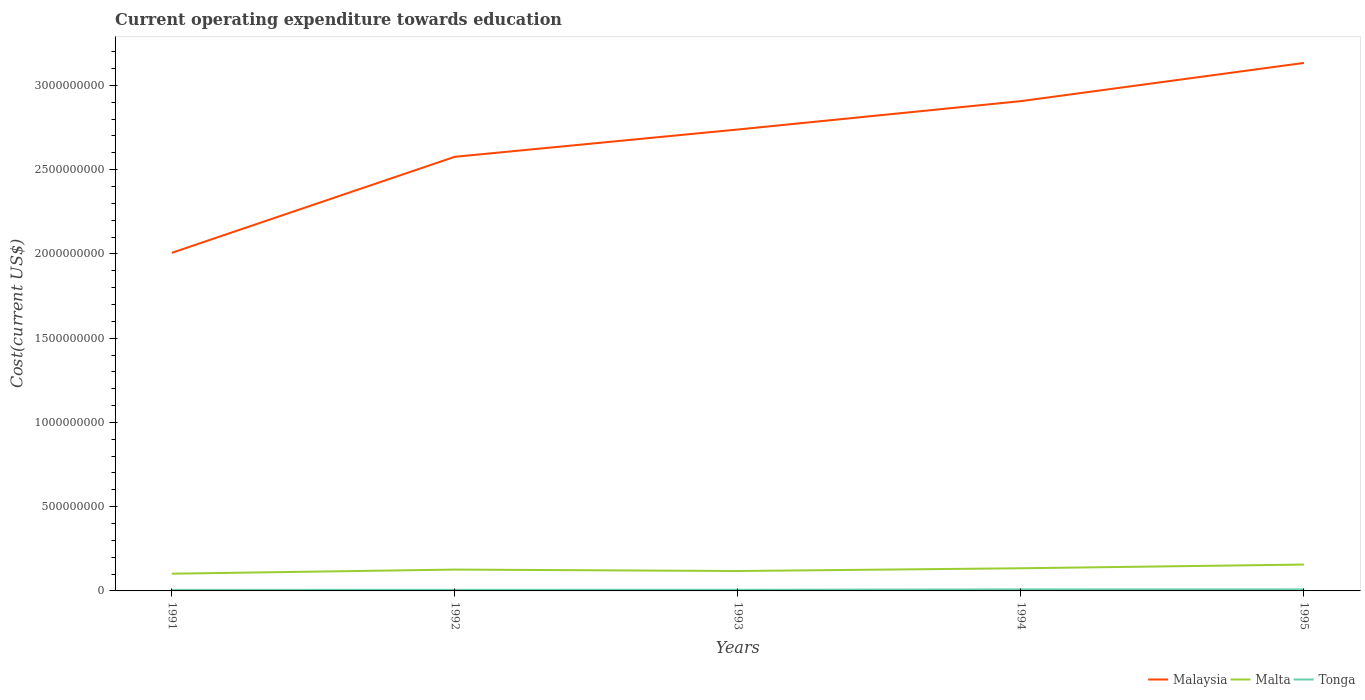Across all years, what is the maximum expenditure towards education in Malaysia?
Your answer should be very brief. 2.01e+09. In which year was the expenditure towards education in Malaysia maximum?
Give a very brief answer. 1991. What is the total expenditure towards education in Tonga in the graph?
Offer a terse response. -5.51e+05. What is the difference between the highest and the second highest expenditure towards education in Malta?
Offer a terse response. 5.43e+07. How many years are there in the graph?
Give a very brief answer. 5. What is the difference between two consecutive major ticks on the Y-axis?
Ensure brevity in your answer.  5.00e+08. Does the graph contain grids?
Your response must be concise. No. Where does the legend appear in the graph?
Your answer should be compact. Bottom right. What is the title of the graph?
Your answer should be compact. Current operating expenditure towards education. Does "Peru" appear as one of the legend labels in the graph?
Offer a terse response. No. What is the label or title of the X-axis?
Provide a short and direct response. Years. What is the label or title of the Y-axis?
Your answer should be compact. Cost(current US$). What is the Cost(current US$) of Malaysia in 1991?
Provide a short and direct response. 2.01e+09. What is the Cost(current US$) in Malta in 1991?
Your answer should be very brief. 1.02e+08. What is the Cost(current US$) of Tonga in 1991?
Give a very brief answer. 6.01e+06. What is the Cost(current US$) of Malaysia in 1992?
Give a very brief answer. 2.58e+09. What is the Cost(current US$) of Malta in 1992?
Make the answer very short. 1.27e+08. What is the Cost(current US$) in Tonga in 1992?
Your response must be concise. 6.35e+06. What is the Cost(current US$) in Malaysia in 1993?
Offer a terse response. 2.74e+09. What is the Cost(current US$) in Malta in 1993?
Offer a very short reply. 1.18e+08. What is the Cost(current US$) of Tonga in 1993?
Offer a terse response. 6.56e+06. What is the Cost(current US$) in Malaysia in 1994?
Your response must be concise. 2.91e+09. What is the Cost(current US$) of Malta in 1994?
Ensure brevity in your answer.  1.34e+08. What is the Cost(current US$) in Tonga in 1994?
Make the answer very short. 9.12e+06. What is the Cost(current US$) in Malaysia in 1995?
Keep it short and to the point. 3.13e+09. What is the Cost(current US$) in Malta in 1995?
Your response must be concise. 1.56e+08. What is the Cost(current US$) of Tonga in 1995?
Ensure brevity in your answer.  8.87e+06. Across all years, what is the maximum Cost(current US$) of Malaysia?
Offer a very short reply. 3.13e+09. Across all years, what is the maximum Cost(current US$) in Malta?
Ensure brevity in your answer.  1.56e+08. Across all years, what is the maximum Cost(current US$) in Tonga?
Make the answer very short. 9.12e+06. Across all years, what is the minimum Cost(current US$) of Malaysia?
Give a very brief answer. 2.01e+09. Across all years, what is the minimum Cost(current US$) in Malta?
Give a very brief answer. 1.02e+08. Across all years, what is the minimum Cost(current US$) of Tonga?
Your answer should be compact. 6.01e+06. What is the total Cost(current US$) of Malaysia in the graph?
Your answer should be very brief. 1.34e+1. What is the total Cost(current US$) of Malta in the graph?
Your response must be concise. 6.38e+08. What is the total Cost(current US$) in Tonga in the graph?
Ensure brevity in your answer.  3.69e+07. What is the difference between the Cost(current US$) in Malaysia in 1991 and that in 1992?
Make the answer very short. -5.70e+08. What is the difference between the Cost(current US$) of Malta in 1991 and that in 1992?
Ensure brevity in your answer.  -2.45e+07. What is the difference between the Cost(current US$) of Tonga in 1991 and that in 1992?
Keep it short and to the point. -3.43e+05. What is the difference between the Cost(current US$) of Malaysia in 1991 and that in 1993?
Keep it short and to the point. -7.32e+08. What is the difference between the Cost(current US$) in Malta in 1991 and that in 1993?
Ensure brevity in your answer.  -1.59e+07. What is the difference between the Cost(current US$) of Tonga in 1991 and that in 1993?
Offer a very short reply. -5.51e+05. What is the difference between the Cost(current US$) of Malaysia in 1991 and that in 1994?
Keep it short and to the point. -9.00e+08. What is the difference between the Cost(current US$) of Malta in 1991 and that in 1994?
Your response must be concise. -3.22e+07. What is the difference between the Cost(current US$) in Tonga in 1991 and that in 1994?
Your answer should be very brief. -3.11e+06. What is the difference between the Cost(current US$) of Malaysia in 1991 and that in 1995?
Make the answer very short. -1.13e+09. What is the difference between the Cost(current US$) in Malta in 1991 and that in 1995?
Ensure brevity in your answer.  -5.43e+07. What is the difference between the Cost(current US$) of Tonga in 1991 and that in 1995?
Offer a very short reply. -2.86e+06. What is the difference between the Cost(current US$) of Malaysia in 1992 and that in 1993?
Your answer should be compact. -1.62e+08. What is the difference between the Cost(current US$) in Malta in 1992 and that in 1993?
Your answer should be compact. 8.56e+06. What is the difference between the Cost(current US$) in Tonga in 1992 and that in 1993?
Give a very brief answer. -2.08e+05. What is the difference between the Cost(current US$) in Malaysia in 1992 and that in 1994?
Provide a short and direct response. -3.30e+08. What is the difference between the Cost(current US$) of Malta in 1992 and that in 1994?
Offer a terse response. -7.78e+06. What is the difference between the Cost(current US$) in Tonga in 1992 and that in 1994?
Make the answer very short. -2.77e+06. What is the difference between the Cost(current US$) in Malaysia in 1992 and that in 1995?
Your answer should be very brief. -5.57e+08. What is the difference between the Cost(current US$) in Malta in 1992 and that in 1995?
Provide a short and direct response. -2.98e+07. What is the difference between the Cost(current US$) in Tonga in 1992 and that in 1995?
Your answer should be very brief. -2.52e+06. What is the difference between the Cost(current US$) in Malaysia in 1993 and that in 1994?
Offer a very short reply. -1.68e+08. What is the difference between the Cost(current US$) in Malta in 1993 and that in 1994?
Provide a short and direct response. -1.63e+07. What is the difference between the Cost(current US$) in Tonga in 1993 and that in 1994?
Your response must be concise. -2.56e+06. What is the difference between the Cost(current US$) of Malaysia in 1993 and that in 1995?
Provide a succinct answer. -3.95e+08. What is the difference between the Cost(current US$) of Malta in 1993 and that in 1995?
Your answer should be compact. -3.83e+07. What is the difference between the Cost(current US$) in Tonga in 1993 and that in 1995?
Your response must be concise. -2.31e+06. What is the difference between the Cost(current US$) of Malaysia in 1994 and that in 1995?
Offer a terse response. -2.27e+08. What is the difference between the Cost(current US$) in Malta in 1994 and that in 1995?
Keep it short and to the point. -2.20e+07. What is the difference between the Cost(current US$) in Tonga in 1994 and that in 1995?
Your response must be concise. 2.50e+05. What is the difference between the Cost(current US$) of Malaysia in 1991 and the Cost(current US$) of Malta in 1992?
Offer a very short reply. 1.88e+09. What is the difference between the Cost(current US$) in Malaysia in 1991 and the Cost(current US$) in Tonga in 1992?
Your answer should be compact. 2.00e+09. What is the difference between the Cost(current US$) of Malta in 1991 and the Cost(current US$) of Tonga in 1992?
Your answer should be compact. 9.58e+07. What is the difference between the Cost(current US$) of Malaysia in 1991 and the Cost(current US$) of Malta in 1993?
Ensure brevity in your answer.  1.89e+09. What is the difference between the Cost(current US$) in Malaysia in 1991 and the Cost(current US$) in Tonga in 1993?
Your response must be concise. 2.00e+09. What is the difference between the Cost(current US$) in Malta in 1991 and the Cost(current US$) in Tonga in 1993?
Make the answer very short. 9.56e+07. What is the difference between the Cost(current US$) of Malaysia in 1991 and the Cost(current US$) of Malta in 1994?
Your answer should be very brief. 1.87e+09. What is the difference between the Cost(current US$) of Malaysia in 1991 and the Cost(current US$) of Tonga in 1994?
Ensure brevity in your answer.  2.00e+09. What is the difference between the Cost(current US$) in Malta in 1991 and the Cost(current US$) in Tonga in 1994?
Offer a very short reply. 9.31e+07. What is the difference between the Cost(current US$) of Malaysia in 1991 and the Cost(current US$) of Malta in 1995?
Make the answer very short. 1.85e+09. What is the difference between the Cost(current US$) in Malaysia in 1991 and the Cost(current US$) in Tonga in 1995?
Provide a succinct answer. 2.00e+09. What is the difference between the Cost(current US$) of Malta in 1991 and the Cost(current US$) of Tonga in 1995?
Provide a short and direct response. 9.33e+07. What is the difference between the Cost(current US$) of Malaysia in 1992 and the Cost(current US$) of Malta in 1993?
Ensure brevity in your answer.  2.46e+09. What is the difference between the Cost(current US$) in Malaysia in 1992 and the Cost(current US$) in Tonga in 1993?
Provide a short and direct response. 2.57e+09. What is the difference between the Cost(current US$) of Malta in 1992 and the Cost(current US$) of Tonga in 1993?
Provide a succinct answer. 1.20e+08. What is the difference between the Cost(current US$) of Malaysia in 1992 and the Cost(current US$) of Malta in 1994?
Offer a very short reply. 2.44e+09. What is the difference between the Cost(current US$) in Malaysia in 1992 and the Cost(current US$) in Tonga in 1994?
Ensure brevity in your answer.  2.57e+09. What is the difference between the Cost(current US$) of Malta in 1992 and the Cost(current US$) of Tonga in 1994?
Offer a very short reply. 1.18e+08. What is the difference between the Cost(current US$) of Malaysia in 1992 and the Cost(current US$) of Malta in 1995?
Provide a short and direct response. 2.42e+09. What is the difference between the Cost(current US$) in Malaysia in 1992 and the Cost(current US$) in Tonga in 1995?
Offer a terse response. 2.57e+09. What is the difference between the Cost(current US$) in Malta in 1992 and the Cost(current US$) in Tonga in 1995?
Make the answer very short. 1.18e+08. What is the difference between the Cost(current US$) of Malaysia in 1993 and the Cost(current US$) of Malta in 1994?
Your response must be concise. 2.60e+09. What is the difference between the Cost(current US$) of Malaysia in 1993 and the Cost(current US$) of Tonga in 1994?
Your response must be concise. 2.73e+09. What is the difference between the Cost(current US$) in Malta in 1993 and the Cost(current US$) in Tonga in 1994?
Offer a very short reply. 1.09e+08. What is the difference between the Cost(current US$) in Malaysia in 1993 and the Cost(current US$) in Malta in 1995?
Provide a succinct answer. 2.58e+09. What is the difference between the Cost(current US$) of Malaysia in 1993 and the Cost(current US$) of Tonga in 1995?
Your answer should be compact. 2.73e+09. What is the difference between the Cost(current US$) of Malta in 1993 and the Cost(current US$) of Tonga in 1995?
Your answer should be very brief. 1.09e+08. What is the difference between the Cost(current US$) in Malaysia in 1994 and the Cost(current US$) in Malta in 1995?
Your answer should be very brief. 2.75e+09. What is the difference between the Cost(current US$) in Malaysia in 1994 and the Cost(current US$) in Tonga in 1995?
Your response must be concise. 2.90e+09. What is the difference between the Cost(current US$) of Malta in 1994 and the Cost(current US$) of Tonga in 1995?
Provide a succinct answer. 1.26e+08. What is the average Cost(current US$) in Malaysia per year?
Offer a very short reply. 2.67e+09. What is the average Cost(current US$) of Malta per year?
Give a very brief answer. 1.28e+08. What is the average Cost(current US$) in Tonga per year?
Provide a short and direct response. 7.38e+06. In the year 1991, what is the difference between the Cost(current US$) in Malaysia and Cost(current US$) in Malta?
Give a very brief answer. 1.90e+09. In the year 1991, what is the difference between the Cost(current US$) in Malaysia and Cost(current US$) in Tonga?
Provide a short and direct response. 2.00e+09. In the year 1991, what is the difference between the Cost(current US$) in Malta and Cost(current US$) in Tonga?
Provide a succinct answer. 9.62e+07. In the year 1992, what is the difference between the Cost(current US$) in Malaysia and Cost(current US$) in Malta?
Provide a succinct answer. 2.45e+09. In the year 1992, what is the difference between the Cost(current US$) of Malaysia and Cost(current US$) of Tonga?
Your answer should be very brief. 2.57e+09. In the year 1992, what is the difference between the Cost(current US$) of Malta and Cost(current US$) of Tonga?
Offer a terse response. 1.20e+08. In the year 1993, what is the difference between the Cost(current US$) of Malaysia and Cost(current US$) of Malta?
Provide a succinct answer. 2.62e+09. In the year 1993, what is the difference between the Cost(current US$) in Malaysia and Cost(current US$) in Tonga?
Keep it short and to the point. 2.73e+09. In the year 1993, what is the difference between the Cost(current US$) in Malta and Cost(current US$) in Tonga?
Your answer should be very brief. 1.12e+08. In the year 1994, what is the difference between the Cost(current US$) of Malaysia and Cost(current US$) of Malta?
Provide a succinct answer. 2.77e+09. In the year 1994, what is the difference between the Cost(current US$) of Malaysia and Cost(current US$) of Tonga?
Your response must be concise. 2.90e+09. In the year 1994, what is the difference between the Cost(current US$) in Malta and Cost(current US$) in Tonga?
Offer a very short reply. 1.25e+08. In the year 1995, what is the difference between the Cost(current US$) in Malaysia and Cost(current US$) in Malta?
Give a very brief answer. 2.98e+09. In the year 1995, what is the difference between the Cost(current US$) of Malaysia and Cost(current US$) of Tonga?
Ensure brevity in your answer.  3.12e+09. In the year 1995, what is the difference between the Cost(current US$) of Malta and Cost(current US$) of Tonga?
Keep it short and to the point. 1.48e+08. What is the ratio of the Cost(current US$) of Malaysia in 1991 to that in 1992?
Provide a succinct answer. 0.78. What is the ratio of the Cost(current US$) in Malta in 1991 to that in 1992?
Ensure brevity in your answer.  0.81. What is the ratio of the Cost(current US$) in Tonga in 1991 to that in 1992?
Offer a very short reply. 0.95. What is the ratio of the Cost(current US$) in Malaysia in 1991 to that in 1993?
Your answer should be very brief. 0.73. What is the ratio of the Cost(current US$) in Malta in 1991 to that in 1993?
Provide a short and direct response. 0.87. What is the ratio of the Cost(current US$) of Tonga in 1991 to that in 1993?
Your answer should be very brief. 0.92. What is the ratio of the Cost(current US$) of Malaysia in 1991 to that in 1994?
Your answer should be compact. 0.69. What is the ratio of the Cost(current US$) in Malta in 1991 to that in 1994?
Keep it short and to the point. 0.76. What is the ratio of the Cost(current US$) of Tonga in 1991 to that in 1994?
Your answer should be compact. 0.66. What is the ratio of the Cost(current US$) of Malaysia in 1991 to that in 1995?
Ensure brevity in your answer.  0.64. What is the ratio of the Cost(current US$) of Malta in 1991 to that in 1995?
Give a very brief answer. 0.65. What is the ratio of the Cost(current US$) in Tonga in 1991 to that in 1995?
Offer a terse response. 0.68. What is the ratio of the Cost(current US$) in Malaysia in 1992 to that in 1993?
Offer a very short reply. 0.94. What is the ratio of the Cost(current US$) of Malta in 1992 to that in 1993?
Your answer should be very brief. 1.07. What is the ratio of the Cost(current US$) of Tonga in 1992 to that in 1993?
Your answer should be compact. 0.97. What is the ratio of the Cost(current US$) in Malaysia in 1992 to that in 1994?
Your answer should be very brief. 0.89. What is the ratio of the Cost(current US$) in Malta in 1992 to that in 1994?
Your answer should be compact. 0.94. What is the ratio of the Cost(current US$) of Tonga in 1992 to that in 1994?
Provide a succinct answer. 0.7. What is the ratio of the Cost(current US$) of Malaysia in 1992 to that in 1995?
Ensure brevity in your answer.  0.82. What is the ratio of the Cost(current US$) of Malta in 1992 to that in 1995?
Your answer should be very brief. 0.81. What is the ratio of the Cost(current US$) in Tonga in 1992 to that in 1995?
Give a very brief answer. 0.72. What is the ratio of the Cost(current US$) in Malaysia in 1993 to that in 1994?
Your answer should be compact. 0.94. What is the ratio of the Cost(current US$) of Malta in 1993 to that in 1994?
Your response must be concise. 0.88. What is the ratio of the Cost(current US$) in Tonga in 1993 to that in 1994?
Your answer should be very brief. 0.72. What is the ratio of the Cost(current US$) of Malaysia in 1993 to that in 1995?
Your response must be concise. 0.87. What is the ratio of the Cost(current US$) in Malta in 1993 to that in 1995?
Your answer should be very brief. 0.75. What is the ratio of the Cost(current US$) in Tonga in 1993 to that in 1995?
Ensure brevity in your answer.  0.74. What is the ratio of the Cost(current US$) in Malaysia in 1994 to that in 1995?
Your response must be concise. 0.93. What is the ratio of the Cost(current US$) in Malta in 1994 to that in 1995?
Offer a very short reply. 0.86. What is the ratio of the Cost(current US$) of Tonga in 1994 to that in 1995?
Make the answer very short. 1.03. What is the difference between the highest and the second highest Cost(current US$) of Malaysia?
Your answer should be compact. 2.27e+08. What is the difference between the highest and the second highest Cost(current US$) in Malta?
Your response must be concise. 2.20e+07. What is the difference between the highest and the second highest Cost(current US$) of Tonga?
Make the answer very short. 2.50e+05. What is the difference between the highest and the lowest Cost(current US$) of Malaysia?
Ensure brevity in your answer.  1.13e+09. What is the difference between the highest and the lowest Cost(current US$) in Malta?
Your response must be concise. 5.43e+07. What is the difference between the highest and the lowest Cost(current US$) in Tonga?
Ensure brevity in your answer.  3.11e+06. 